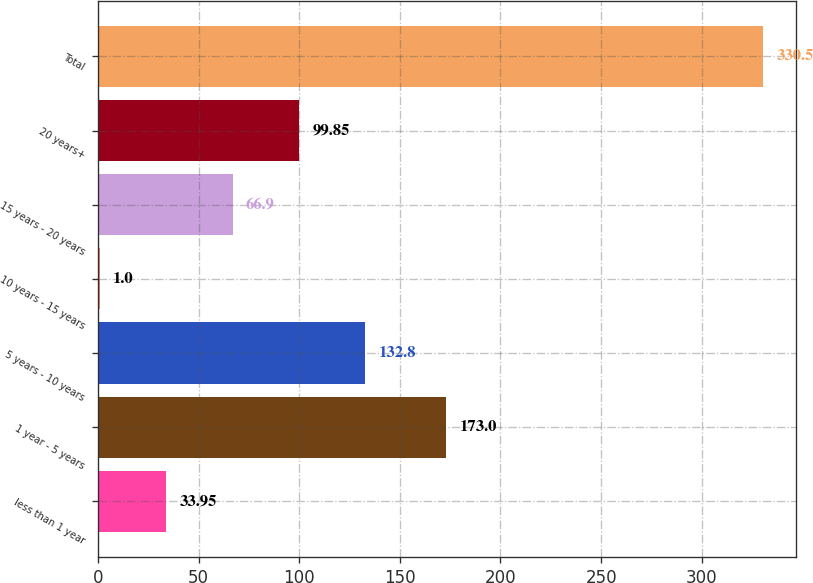Convert chart. <chart><loc_0><loc_0><loc_500><loc_500><bar_chart><fcel>less than 1 year<fcel>1 year - 5 years<fcel>5 years - 10 years<fcel>10 years - 15 years<fcel>15 years - 20 years<fcel>20 years+<fcel>Total<nl><fcel>33.95<fcel>173<fcel>132.8<fcel>1<fcel>66.9<fcel>99.85<fcel>330.5<nl></chart> 